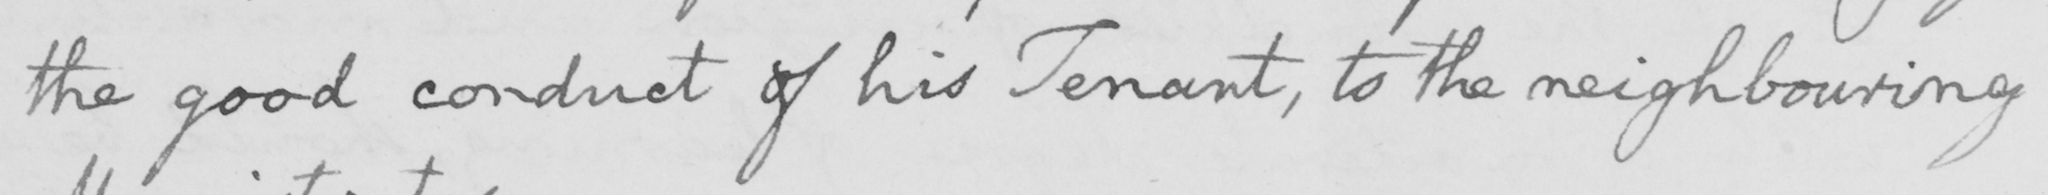Can you read and transcribe this handwriting? the good conduct of his Tenant , to the neighbouring 